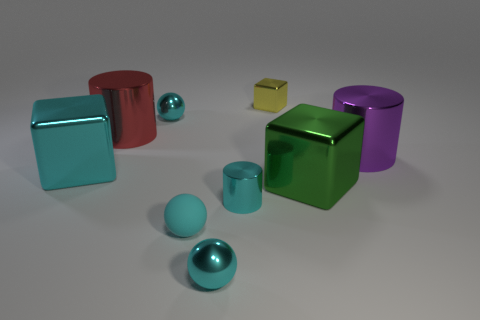There is a cyan ball behind the green metallic block; is its size the same as the big green thing?
Offer a terse response. No. Are there any big metal cylinders that have the same color as the small shiny cylinder?
Provide a succinct answer. No. What size is the cyan cylinder that is the same material as the red cylinder?
Provide a short and direct response. Small. Is the number of cyan metal blocks that are in front of the tiny cube greater than the number of large green shiny things behind the large red shiny object?
Provide a short and direct response. Yes. What number of other objects are the same material as the yellow block?
Keep it short and to the point. 7. What is the shape of the big red thing?
Provide a short and direct response. Cylinder. Are there more small cyan objects that are in front of the red metallic cylinder than cyan shiny cylinders?
Ensure brevity in your answer.  Yes. The other small object that is the same shape as the green object is what color?
Ensure brevity in your answer.  Yellow. There is a small cyan metal thing that is behind the purple thing; what shape is it?
Provide a succinct answer. Sphere. Are there any cyan balls on the left side of the small rubber ball?
Offer a very short reply. Yes. 